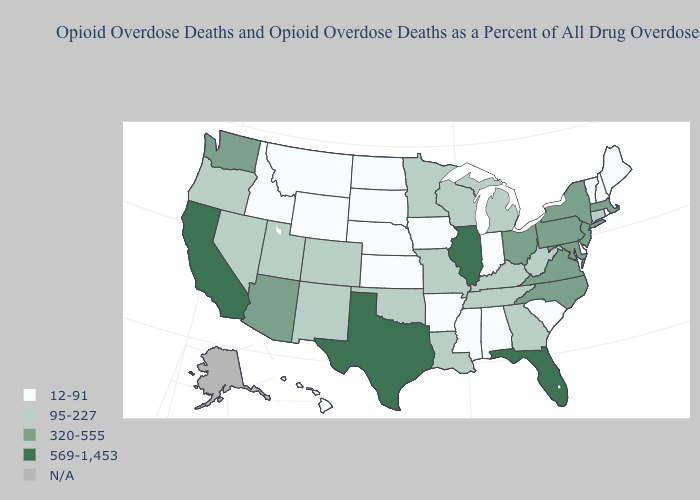Does the map have missing data?
Short answer required. Yes. Name the states that have a value in the range 95-227?
Write a very short answer. Colorado, Connecticut, Georgia, Kentucky, Louisiana, Michigan, Minnesota, Missouri, Nevada, New Mexico, Oklahoma, Oregon, Tennessee, Utah, West Virginia, Wisconsin. Name the states that have a value in the range 569-1,453?
Answer briefly. California, Florida, Illinois, Texas. Name the states that have a value in the range 95-227?
Quick response, please. Colorado, Connecticut, Georgia, Kentucky, Louisiana, Michigan, Minnesota, Missouri, Nevada, New Mexico, Oklahoma, Oregon, Tennessee, Utah, West Virginia, Wisconsin. What is the lowest value in the USA?
Be succinct. 12-91. Name the states that have a value in the range 569-1,453?
Answer briefly. California, Florida, Illinois, Texas. What is the highest value in the USA?
Give a very brief answer. 569-1,453. Which states have the highest value in the USA?
Concise answer only. California, Florida, Illinois, Texas. Which states hav the highest value in the Northeast?
Write a very short answer. Massachusetts, New Jersey, New York, Pennsylvania. Which states have the highest value in the USA?
Keep it brief. California, Florida, Illinois, Texas. Does Colorado have the lowest value in the USA?
Be succinct. No. What is the lowest value in the Northeast?
Give a very brief answer. 12-91. Among the states that border Arkansas , which have the highest value?
Answer briefly. Texas. Among the states that border Massachusetts , does Rhode Island have the lowest value?
Write a very short answer. Yes. 